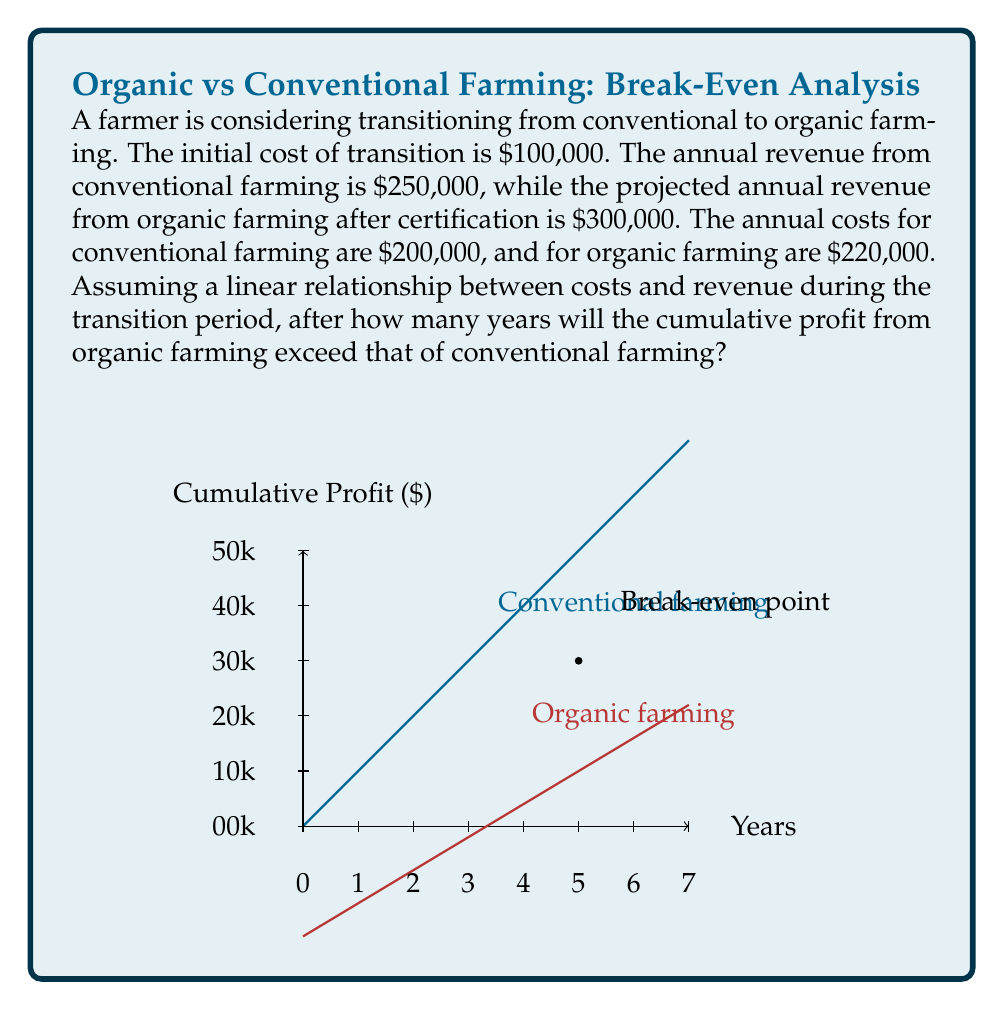Teach me how to tackle this problem. Let's approach this step-by-step:

1) First, let's define our variables:
   Let $x$ be the number of years after transition
   Let $P_o(x)$ be the cumulative profit from organic farming after $x$ years
   Let $P_c(x)$ be the cumulative profit from conventional farming after $x$ years

2) For conventional farming:
   Annual profit = Revenue - Costs = $250,000 - $200,000 = $50,000
   Cumulative profit after $x$ years: $P_c(x) = 50000x$

3) For organic farming:
   Annual profit after transition = Revenue - Costs = $300,000 - $220,000 = $80,000
   But we need to account for the initial transition cost of $100,000
   Cumulative profit after $x$ years: $P_o(x) = 80000x - 100000$

4) To find the break-even point, we set these equal:
   $P_c(x) = P_o(x)$
   $50000x = 80000x - 100000$

5) Solve for $x$:
   $50000x = 80000x - 100000$
   $-30000x = -100000$
   $x = \frac{100000}{30000} = \frac{10}{3} \approx 3.33$ years

6) However, the question asks for when organic farming will exceed conventional farming, so we need the next whole number of years:
   $x = 4$ years

7) We can verify:
   At 3 years: $P_c(3) = 150000$, $P_o(3) = 140000$
   At 4 years: $P_c(4) = 200000$, $P_o(4) = 220000$

Therefore, after 4 years, the cumulative profit from organic farming will exceed that of conventional farming.
Answer: 4 years 